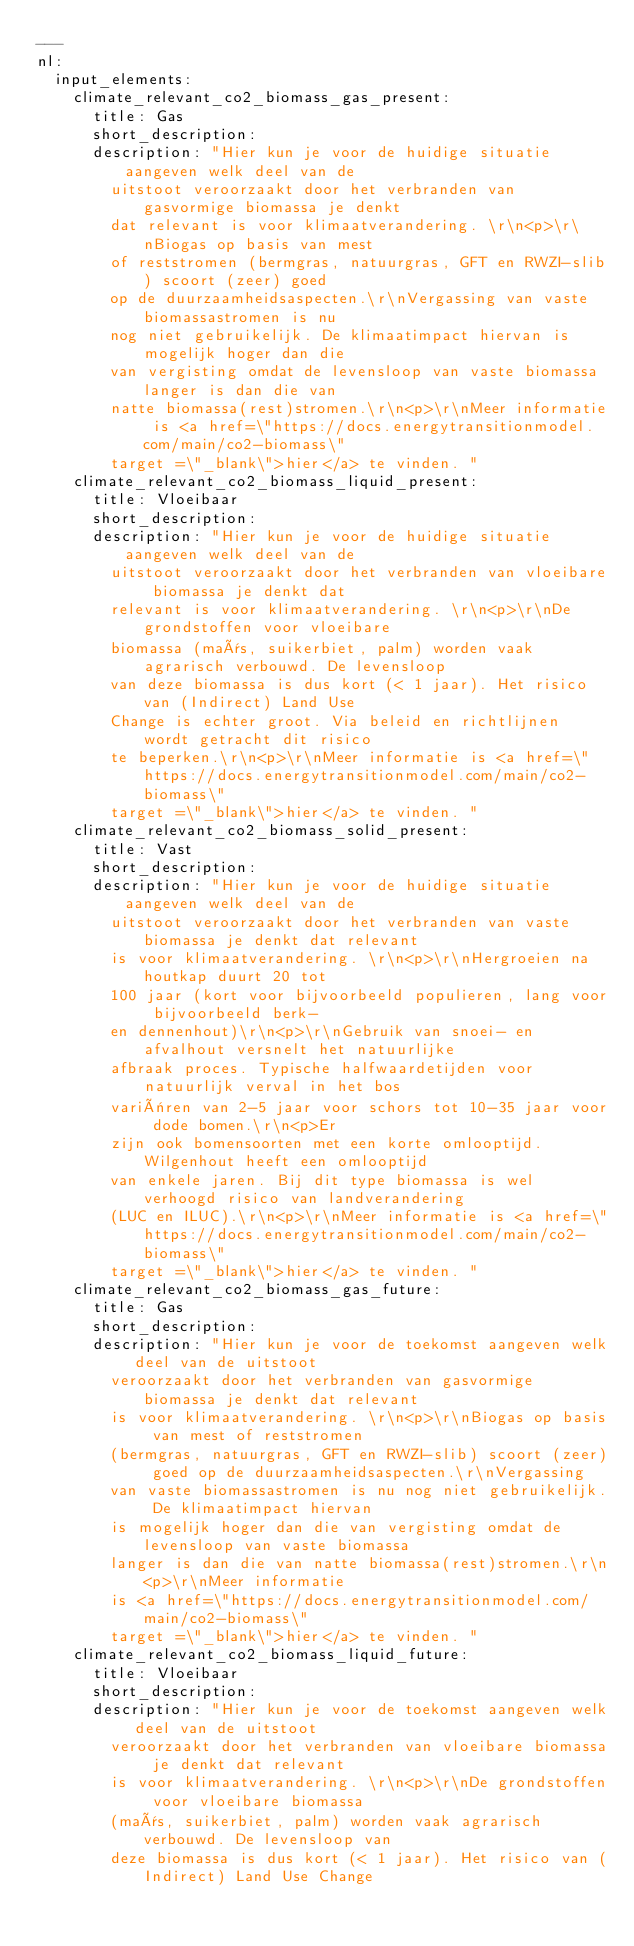Convert code to text. <code><loc_0><loc_0><loc_500><loc_500><_YAML_>---
nl:
  input_elements:
    climate_relevant_co2_biomass_gas_present:
      title: Gas
      short_description:
      description: "Hier kun je voor de huidige situatie aangeven welk deel van de
        uitstoot veroorzaakt door het verbranden van gasvormige biomassa je denkt
        dat relevant is voor klimaatverandering. \r\n<p>\r\nBiogas op basis van mest
        of reststromen (bermgras, natuurgras, GFT en RWZI-slib) scoort (zeer) goed
        op de duurzaamheidsaspecten.\r\nVergassing van vaste biomassastromen is nu
        nog niet gebruikelijk. De klimaatimpact hiervan is mogelijk hoger dan die
        van vergisting omdat de levensloop van vaste biomassa langer is dan die van
        natte biomassa(rest)stromen.\r\n<p>\r\nMeer informatie is <a href=\"https://docs.energytransitionmodel.com/main/co2-biomass\"
        target =\"_blank\">hier</a> te vinden. "
    climate_relevant_co2_biomass_liquid_present:
      title: Vloeibaar
      short_description:
      description: "Hier kun je voor de huidige situatie aangeven welk deel van de
        uitstoot veroorzaakt door het verbranden van vloeibare biomassa je denkt dat
        relevant is voor klimaatverandering. \r\n<p>\r\nDe grondstoffen voor vloeibare
        biomassa (maïs, suikerbiet, palm) worden vaak agrarisch verbouwd. De levensloop
        van deze biomassa is dus kort (< 1 jaar). Het risico van (Indirect) Land Use
        Change is echter groot. Via beleid en richtlijnen wordt getracht dit risico
        te beperken.\r\n<p>\r\nMeer informatie is <a href=\"https://docs.energytransitionmodel.com/main/co2-biomass\"
        target =\"_blank\">hier</a> te vinden. "
    climate_relevant_co2_biomass_solid_present:
      title: Vast
      short_description:
      description: "Hier kun je voor de huidige situatie aangeven welk deel van de
        uitstoot veroorzaakt door het verbranden van vaste biomassa je denkt dat relevant
        is voor klimaatverandering. \r\n<p>\r\nHergroeien na houtkap duurt 20 tot
        100 jaar (kort voor bijvoorbeeld populieren, lang voor bijvoorbeeld berk-
        en dennenhout)\r\n<p>\r\nGebruik van snoei- en afvalhout versnelt het natuurlijke
        afbraak proces. Typische halfwaardetijden voor natuurlijk verval in het bos
        variëren van 2-5 jaar voor schors tot 10-35 jaar voor dode bomen.\r\n<p>Er
        zijn ook bomensoorten met een korte omlooptijd. Wilgenhout heeft een omlooptijd
        van enkele jaren. Bij dit type biomassa is wel verhoogd risico van landverandering
        (LUC en ILUC).\r\n<p>\r\nMeer informatie is <a href=\"https://docs.energytransitionmodel.com/main/co2-biomass\"
        target =\"_blank\">hier</a> te vinden. "
    climate_relevant_co2_biomass_gas_future:
      title: Gas
      short_description:
      description: "Hier kun je voor de toekomst aangeven welk deel van de uitstoot
        veroorzaakt door het verbranden van gasvormige biomassa je denkt dat relevant
        is voor klimaatverandering. \r\n<p>\r\nBiogas op basis van mest of reststromen
        (bermgras, natuurgras, GFT en RWZI-slib) scoort (zeer) goed op de duurzaamheidsaspecten.\r\nVergassing
        van vaste biomassastromen is nu nog niet gebruikelijk. De klimaatimpact hiervan
        is mogelijk hoger dan die van vergisting omdat de levensloop van vaste biomassa
        langer is dan die van natte biomassa(rest)stromen.\r\n<p>\r\nMeer informatie
        is <a href=\"https://docs.energytransitionmodel.com/main/co2-biomass\"
        target =\"_blank\">hier</a> te vinden. "
    climate_relevant_co2_biomass_liquid_future:
      title: Vloeibaar
      short_description:
      description: "Hier kun je voor de toekomst aangeven welk deel van de uitstoot
        veroorzaakt door het verbranden van vloeibare biomassa je denkt dat relevant
        is voor klimaatverandering. \r\n<p>\r\nDe grondstoffen voor vloeibare biomassa
        (maïs, suikerbiet, palm) worden vaak agrarisch verbouwd. De levensloop van
        deze biomassa is dus kort (< 1 jaar). Het risico van (Indirect) Land Use Change</code> 